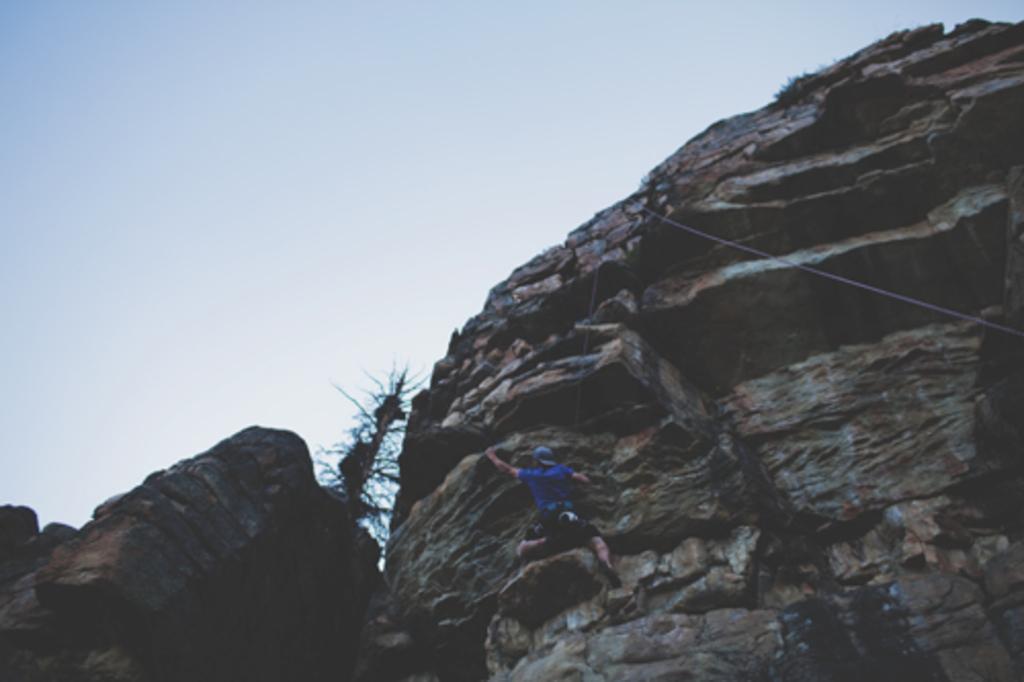Can you describe this image briefly? In the middle of the image we can see a man, he is climbing the rock and we can see a rope. 